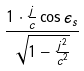Convert formula to latex. <formula><loc_0><loc_0><loc_500><loc_500>\frac { 1 \cdot \frac { j } { c } \cos \epsilon _ { s } } { \sqrt { 1 - \frac { j ^ { 2 } } { c ^ { 2 } } } }</formula> 